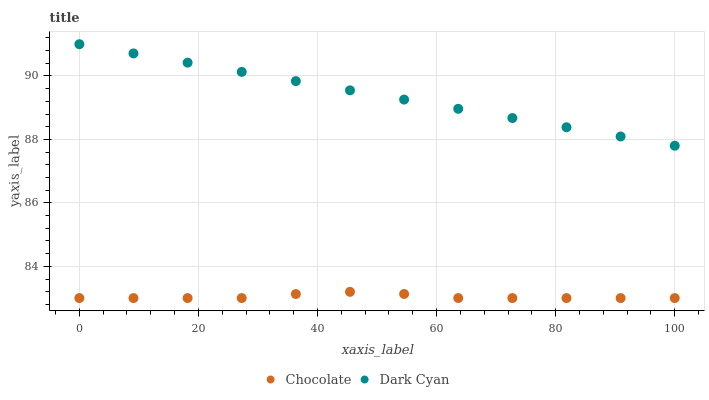Does Chocolate have the minimum area under the curve?
Answer yes or no. Yes. Does Dark Cyan have the maximum area under the curve?
Answer yes or no. Yes. Does Chocolate have the maximum area under the curve?
Answer yes or no. No. Is Dark Cyan the smoothest?
Answer yes or no. Yes. Is Chocolate the roughest?
Answer yes or no. Yes. Is Chocolate the smoothest?
Answer yes or no. No. Does Chocolate have the lowest value?
Answer yes or no. Yes. Does Dark Cyan have the highest value?
Answer yes or no. Yes. Does Chocolate have the highest value?
Answer yes or no. No. Is Chocolate less than Dark Cyan?
Answer yes or no. Yes. Is Dark Cyan greater than Chocolate?
Answer yes or no. Yes. Does Chocolate intersect Dark Cyan?
Answer yes or no. No. 